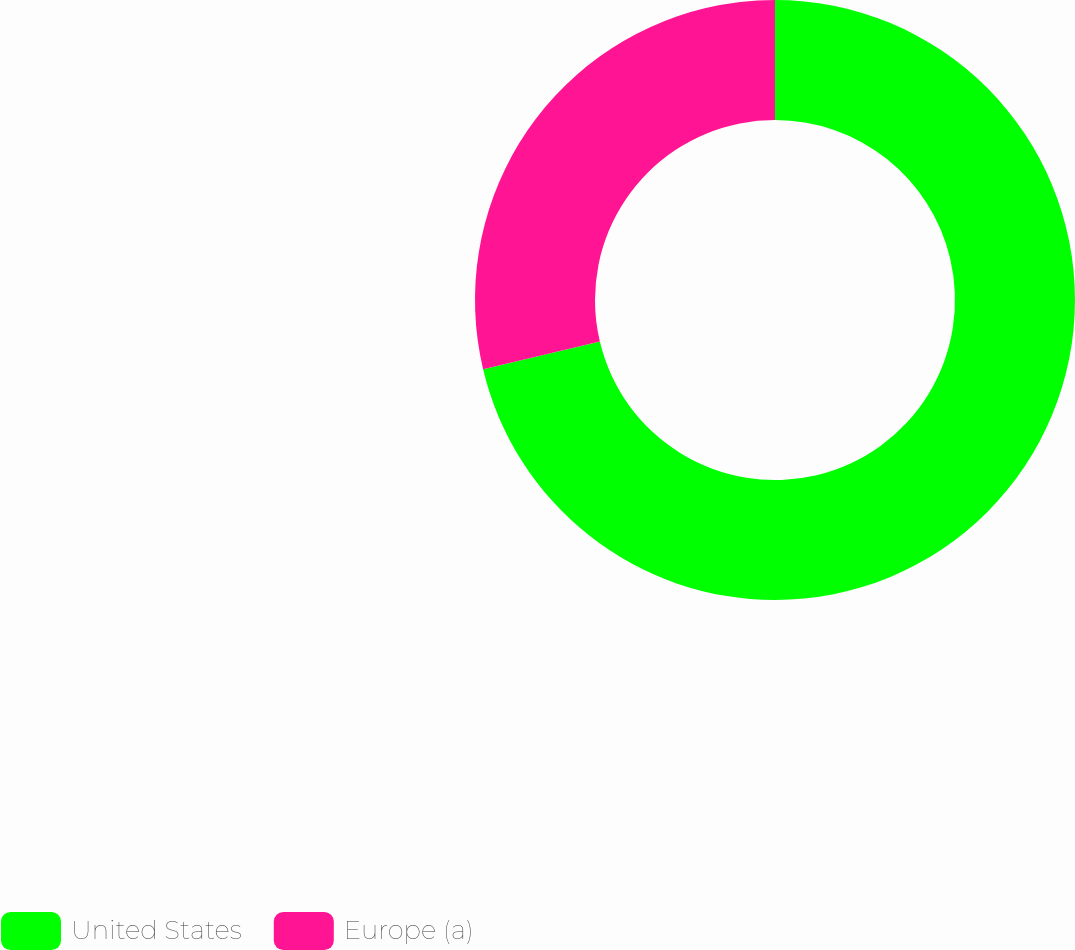<chart> <loc_0><loc_0><loc_500><loc_500><pie_chart><fcel>United States<fcel>Europe (a)<nl><fcel>71.29%<fcel>28.71%<nl></chart> 